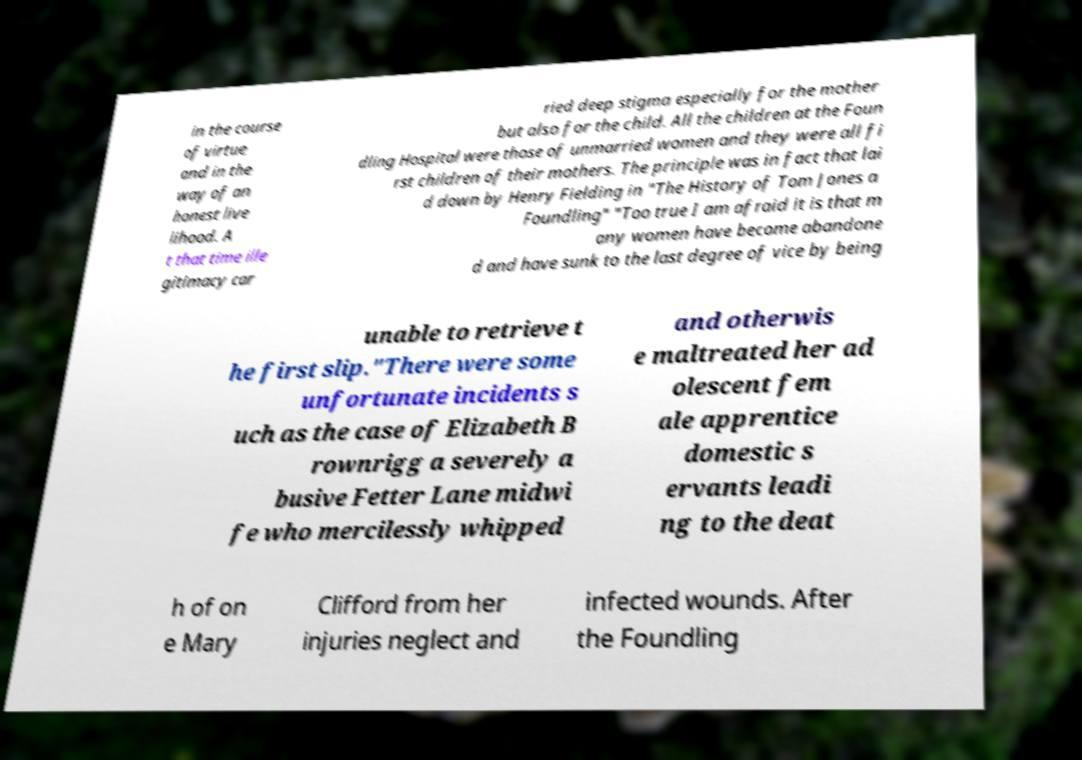Please identify and transcribe the text found in this image. in the course of virtue and in the way of an honest live lihood. A t that time ille gitimacy car ried deep stigma especially for the mother but also for the child. All the children at the Foun dling Hospital were those of unmarried women and they were all fi rst children of their mothers. The principle was in fact that lai d down by Henry Fielding in "The History of Tom Jones a Foundling" "Too true I am afraid it is that m any women have become abandone d and have sunk to the last degree of vice by being unable to retrieve t he first slip."There were some unfortunate incidents s uch as the case of Elizabeth B rownrigg a severely a busive Fetter Lane midwi fe who mercilessly whipped and otherwis e maltreated her ad olescent fem ale apprentice domestic s ervants leadi ng to the deat h of on e Mary Clifford from her injuries neglect and infected wounds. After the Foundling 